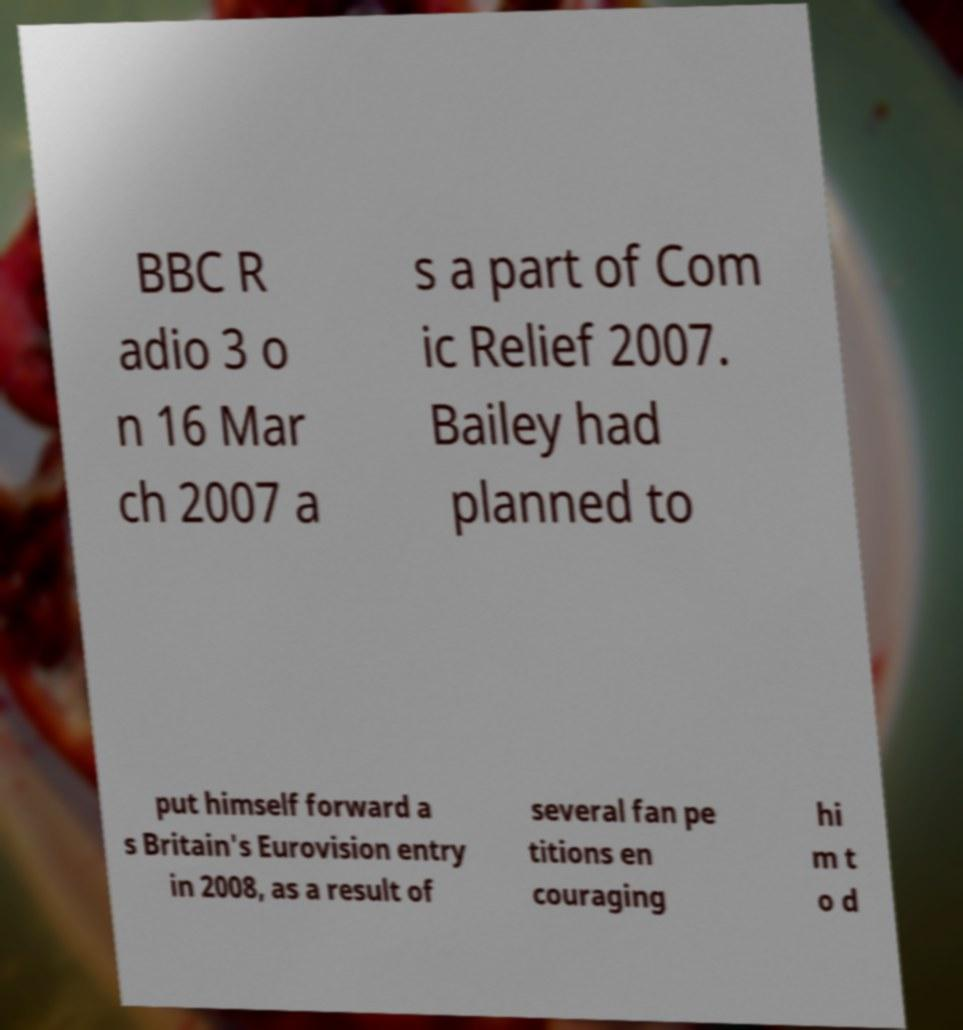Please read and relay the text visible in this image. What does it say? BBC R adio 3 o n 16 Mar ch 2007 a s a part of Com ic Relief 2007. Bailey had planned to put himself forward a s Britain's Eurovision entry in 2008, as a result of several fan pe titions en couraging hi m t o d 